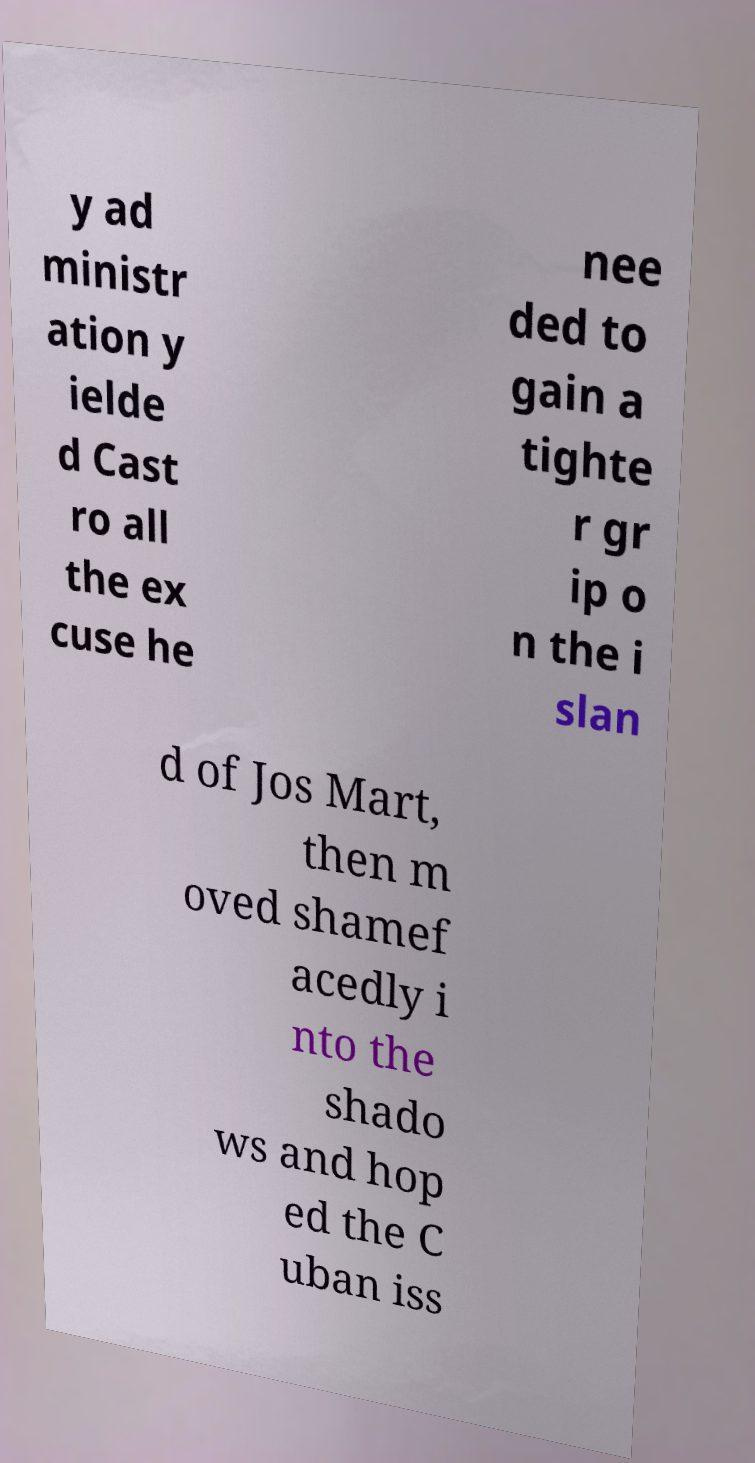Can you accurately transcribe the text from the provided image for me? y ad ministr ation y ielde d Cast ro all the ex cuse he nee ded to gain a tighte r gr ip o n the i slan d of Jos Mart, then m oved shamef acedly i nto the shado ws and hop ed the C uban iss 